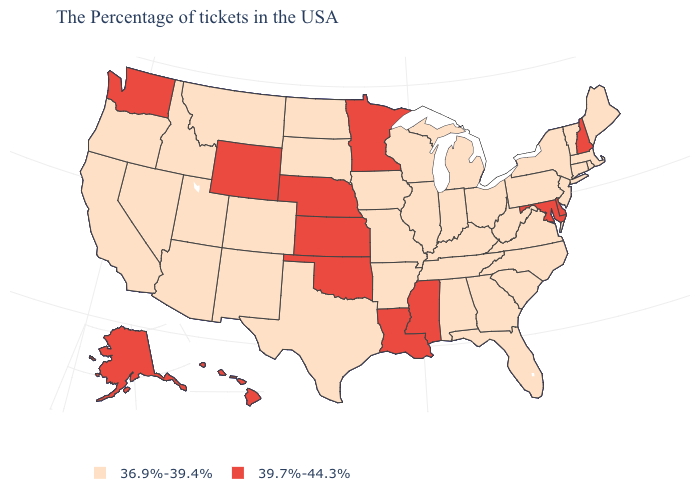Does Virginia have a higher value than Maine?
Short answer required. No. Name the states that have a value in the range 36.9%-39.4%?
Answer briefly. Maine, Massachusetts, Rhode Island, Vermont, Connecticut, New York, New Jersey, Pennsylvania, Virginia, North Carolina, South Carolina, West Virginia, Ohio, Florida, Georgia, Michigan, Kentucky, Indiana, Alabama, Tennessee, Wisconsin, Illinois, Missouri, Arkansas, Iowa, Texas, South Dakota, North Dakota, Colorado, New Mexico, Utah, Montana, Arizona, Idaho, Nevada, California, Oregon. Name the states that have a value in the range 36.9%-39.4%?
Concise answer only. Maine, Massachusetts, Rhode Island, Vermont, Connecticut, New York, New Jersey, Pennsylvania, Virginia, North Carolina, South Carolina, West Virginia, Ohio, Florida, Georgia, Michigan, Kentucky, Indiana, Alabama, Tennessee, Wisconsin, Illinois, Missouri, Arkansas, Iowa, Texas, South Dakota, North Dakota, Colorado, New Mexico, Utah, Montana, Arizona, Idaho, Nevada, California, Oregon. What is the lowest value in the USA?
Quick response, please. 36.9%-39.4%. Name the states that have a value in the range 39.7%-44.3%?
Quick response, please. New Hampshire, Delaware, Maryland, Mississippi, Louisiana, Minnesota, Kansas, Nebraska, Oklahoma, Wyoming, Washington, Alaska, Hawaii. Does Rhode Island have the lowest value in the Northeast?
Write a very short answer. Yes. Name the states that have a value in the range 36.9%-39.4%?
Give a very brief answer. Maine, Massachusetts, Rhode Island, Vermont, Connecticut, New York, New Jersey, Pennsylvania, Virginia, North Carolina, South Carolina, West Virginia, Ohio, Florida, Georgia, Michigan, Kentucky, Indiana, Alabama, Tennessee, Wisconsin, Illinois, Missouri, Arkansas, Iowa, Texas, South Dakota, North Dakota, Colorado, New Mexico, Utah, Montana, Arizona, Idaho, Nevada, California, Oregon. Does Hawaii have the lowest value in the West?
Write a very short answer. No. Name the states that have a value in the range 36.9%-39.4%?
Quick response, please. Maine, Massachusetts, Rhode Island, Vermont, Connecticut, New York, New Jersey, Pennsylvania, Virginia, North Carolina, South Carolina, West Virginia, Ohio, Florida, Georgia, Michigan, Kentucky, Indiana, Alabama, Tennessee, Wisconsin, Illinois, Missouri, Arkansas, Iowa, Texas, South Dakota, North Dakota, Colorado, New Mexico, Utah, Montana, Arizona, Idaho, Nevada, California, Oregon. What is the highest value in the MidWest ?
Give a very brief answer. 39.7%-44.3%. Name the states that have a value in the range 39.7%-44.3%?
Answer briefly. New Hampshire, Delaware, Maryland, Mississippi, Louisiana, Minnesota, Kansas, Nebraska, Oklahoma, Wyoming, Washington, Alaska, Hawaii. Name the states that have a value in the range 36.9%-39.4%?
Short answer required. Maine, Massachusetts, Rhode Island, Vermont, Connecticut, New York, New Jersey, Pennsylvania, Virginia, North Carolina, South Carolina, West Virginia, Ohio, Florida, Georgia, Michigan, Kentucky, Indiana, Alabama, Tennessee, Wisconsin, Illinois, Missouri, Arkansas, Iowa, Texas, South Dakota, North Dakota, Colorado, New Mexico, Utah, Montana, Arizona, Idaho, Nevada, California, Oregon. Name the states that have a value in the range 36.9%-39.4%?
Concise answer only. Maine, Massachusetts, Rhode Island, Vermont, Connecticut, New York, New Jersey, Pennsylvania, Virginia, North Carolina, South Carolina, West Virginia, Ohio, Florida, Georgia, Michigan, Kentucky, Indiana, Alabama, Tennessee, Wisconsin, Illinois, Missouri, Arkansas, Iowa, Texas, South Dakota, North Dakota, Colorado, New Mexico, Utah, Montana, Arizona, Idaho, Nevada, California, Oregon. What is the highest value in the USA?
Be succinct. 39.7%-44.3%. What is the lowest value in the USA?
Answer briefly. 36.9%-39.4%. 